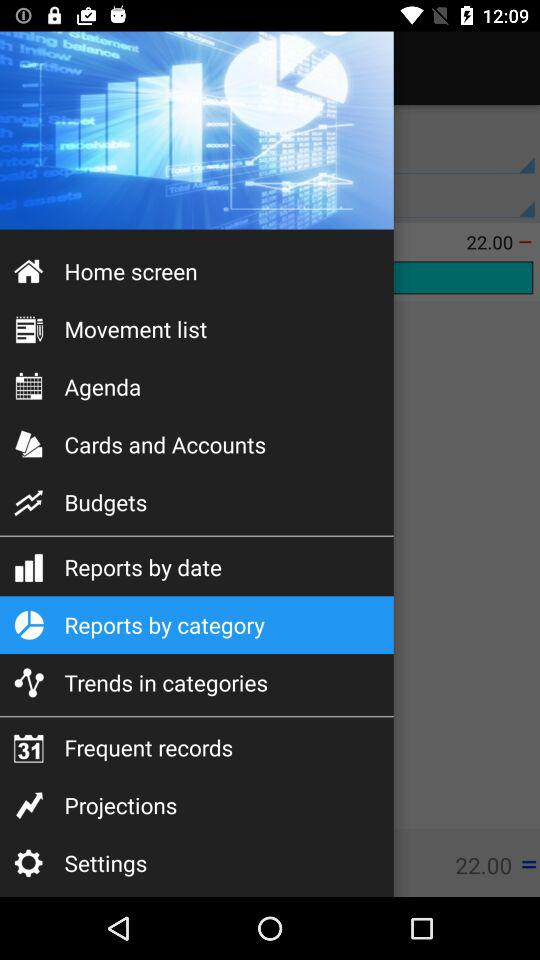How many notifications are there in "Settings"?
When the provided information is insufficient, respond with <no answer>. <no answer> 